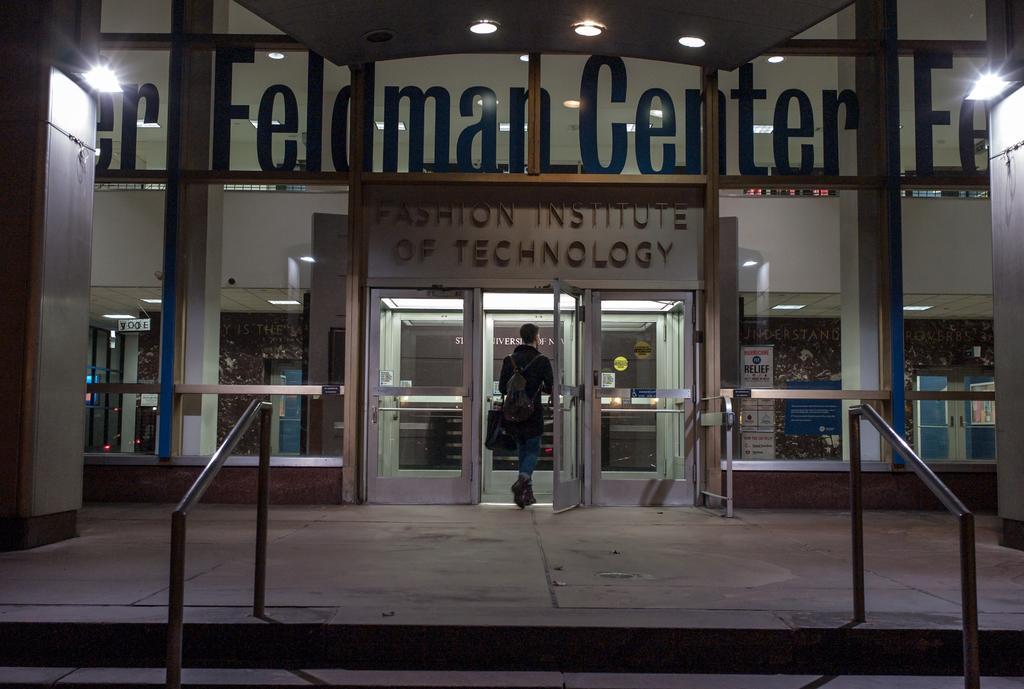Please provide a concise description of this image. In this image, in the middle, we can see a person wearing a backpack is walking. In the background, we can see a building, glass door, glass window and some text written on it, pillars. At the top, we can see a roof with few lights, at the bottom, we can see few metal rods and a floor. 